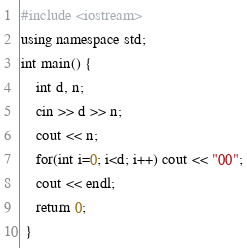Convert code to text. <code><loc_0><loc_0><loc_500><loc_500><_C++_>#include <iostream>
using namespace std;
int main() {
    int d, n;
    cin >> d >> n;
    cout << n;
    for(int i=0; i<d; i++) cout << "00";
    cout << endl;
    return 0; 
 }</code> 